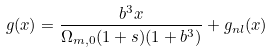Convert formula to latex. <formula><loc_0><loc_0><loc_500><loc_500>g ( x ) = \frac { b ^ { 3 } x } { \Omega _ { m , 0 } ( 1 + s ) ( 1 + b ^ { 3 } ) } + g _ { n l } ( x )</formula> 